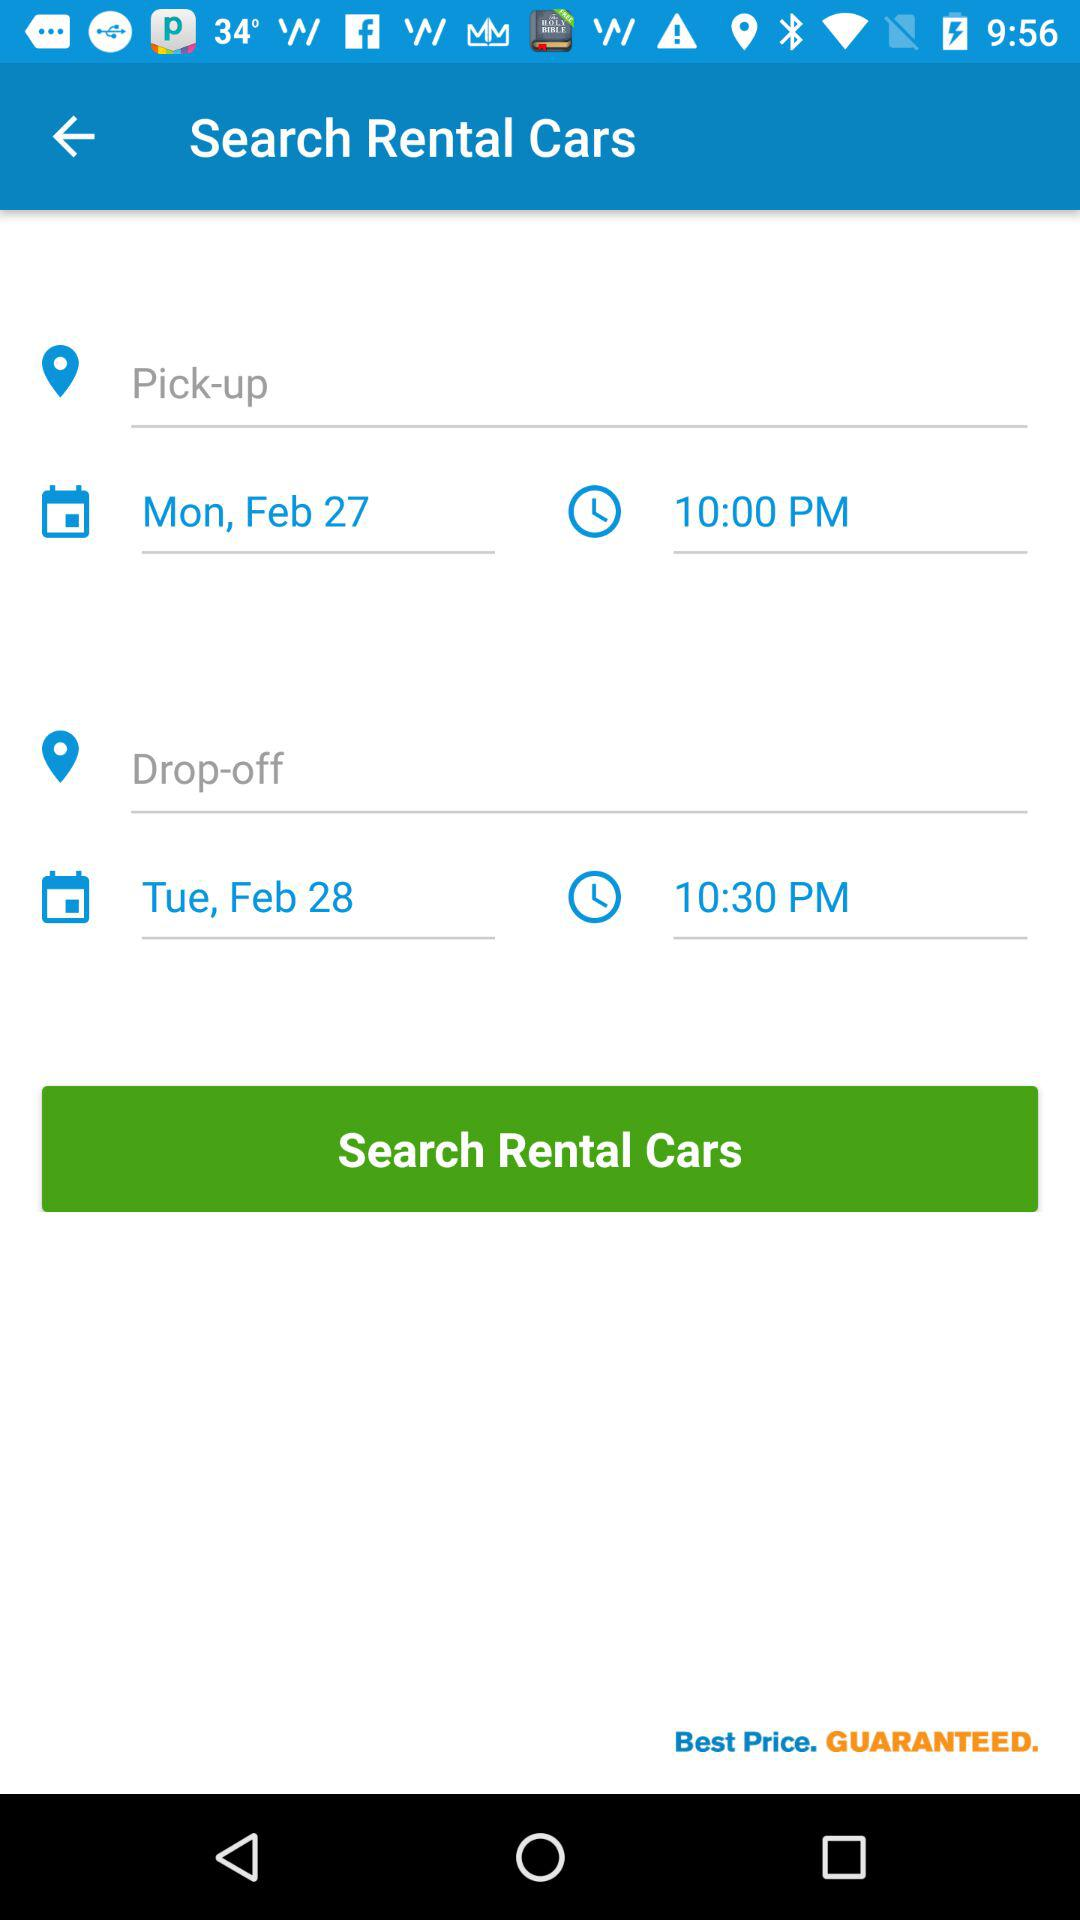What time is the pick-up scheduled? The pick-up is scheduled for 10:00 p.m. 